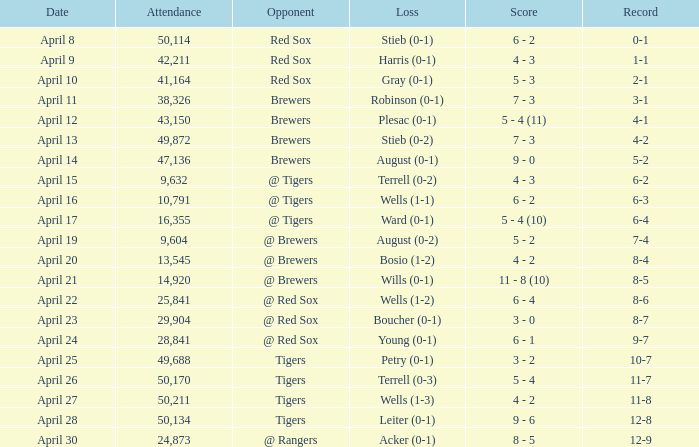I'm looking to parse the entire table for insights. Could you assist me with that? {'header': ['Date', 'Attendance', 'Opponent', 'Loss', 'Score', 'Record'], 'rows': [['April 8', '50,114', 'Red Sox', 'Stieb (0-1)', '6 - 2', '0-1'], ['April 9', '42,211', 'Red Sox', 'Harris (0-1)', '4 - 3', '1-1'], ['April 10', '41,164', 'Red Sox', 'Gray (0-1)', '5 - 3', '2-1'], ['April 11', '38,326', 'Brewers', 'Robinson (0-1)', '7 - 3', '3-1'], ['April 12', '43,150', 'Brewers', 'Plesac (0-1)', '5 - 4 (11)', '4-1'], ['April 13', '49,872', 'Brewers', 'Stieb (0-2)', '7 - 3', '4-2'], ['April 14', '47,136', 'Brewers', 'August (0-1)', '9 - 0', '5-2'], ['April 15', '9,632', '@ Tigers', 'Terrell (0-2)', '4 - 3', '6-2'], ['April 16', '10,791', '@ Tigers', 'Wells (1-1)', '6 - 2', '6-3'], ['April 17', '16,355', '@ Tigers', 'Ward (0-1)', '5 - 4 (10)', '6-4'], ['April 19', '9,604', '@ Brewers', 'August (0-2)', '5 - 2', '7-4'], ['April 20', '13,545', '@ Brewers', 'Bosio (1-2)', '4 - 2', '8-4'], ['April 21', '14,920', '@ Brewers', 'Wills (0-1)', '11 - 8 (10)', '8-5'], ['April 22', '25,841', '@ Red Sox', 'Wells (1-2)', '6 - 4', '8-6'], ['April 23', '29,904', '@ Red Sox', 'Boucher (0-1)', '3 - 0', '8-7'], ['April 24', '28,841', '@ Red Sox', 'Young (0-1)', '6 - 1', '9-7'], ['April 25', '49,688', 'Tigers', 'Petry (0-1)', '3 - 2', '10-7'], ['April 26', '50,170', 'Tigers', 'Terrell (0-3)', '5 - 4', '11-7'], ['April 27', '50,211', 'Tigers', 'Wells (1-3)', '4 - 2', '11-8'], ['April 28', '50,134', 'Tigers', 'Leiter (0-1)', '9 - 6', '12-8'], ['April 30', '24,873', '@ Rangers', 'Acker (0-1)', '8 - 5', '12-9']]} Which opponent has a loss of wells (1-3)? Tigers. 